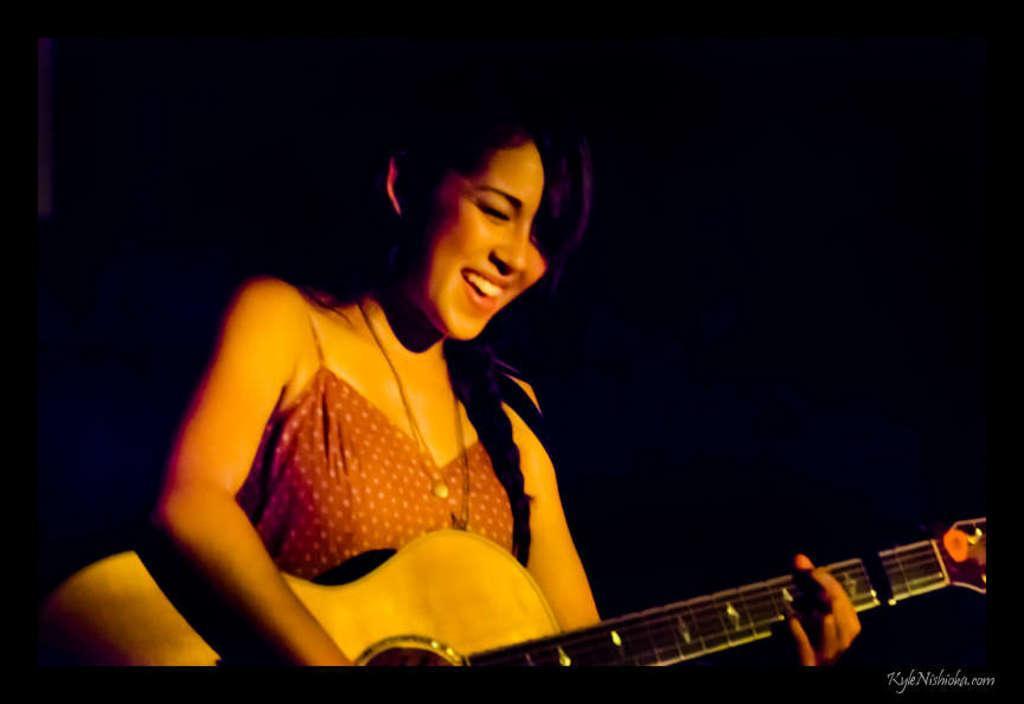How would you summarize this image in a sentence or two? Here we can see that a woman is standing and smiling, and holding a guitar in her hand. 